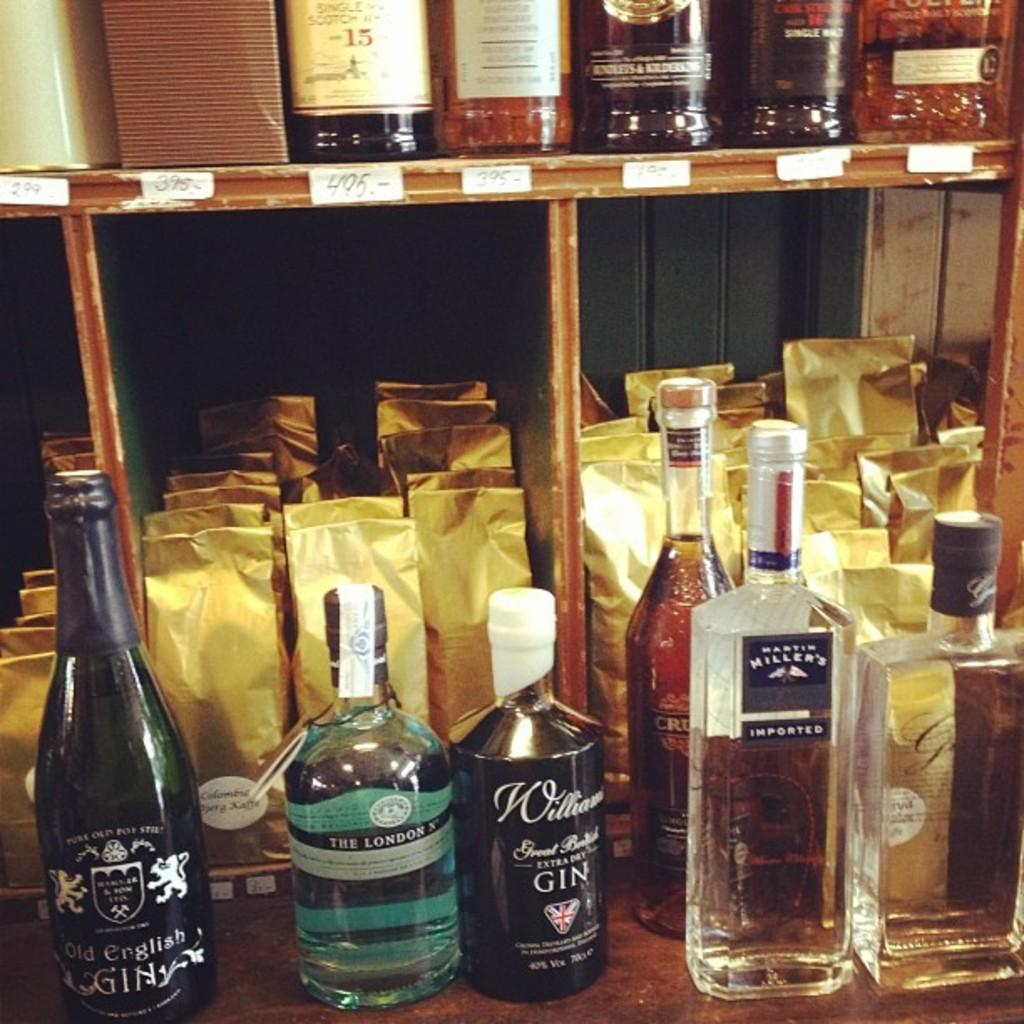<image>
Describe the image concisely. Liquor store with bottles of gin lined up in front 